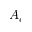Convert formula to latex. <formula><loc_0><loc_0><loc_500><loc_500>A _ { c }</formula> 